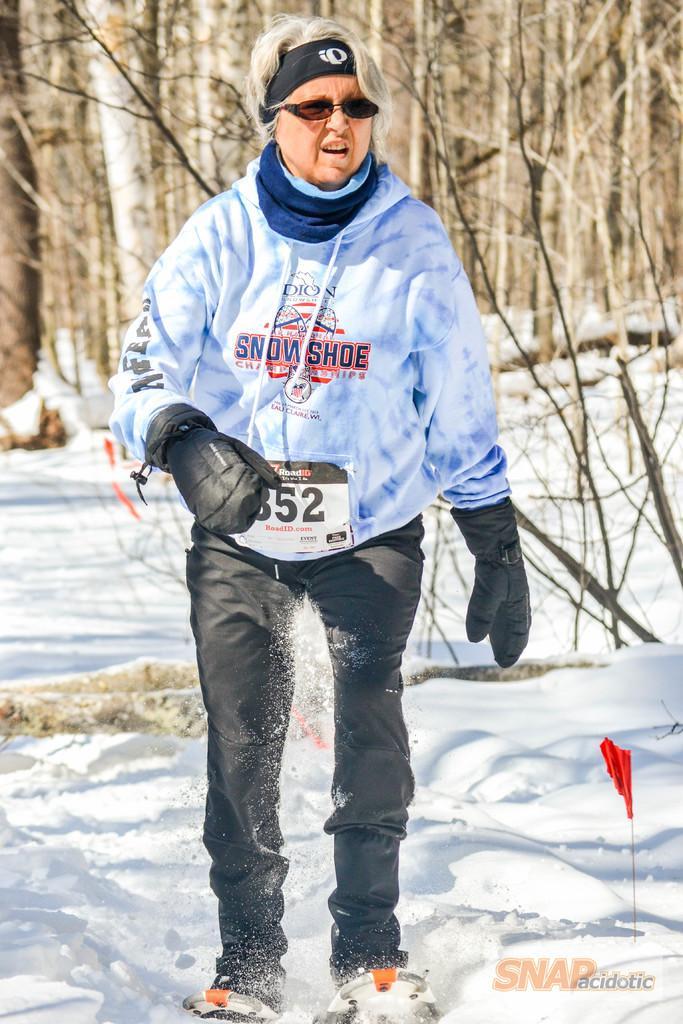Please provide a concise description of this image. The woman in blue t-shirt and black trouser is highlighted. She wore gloves, goggles. Far there are number of bare trees. Snow is in white color. 